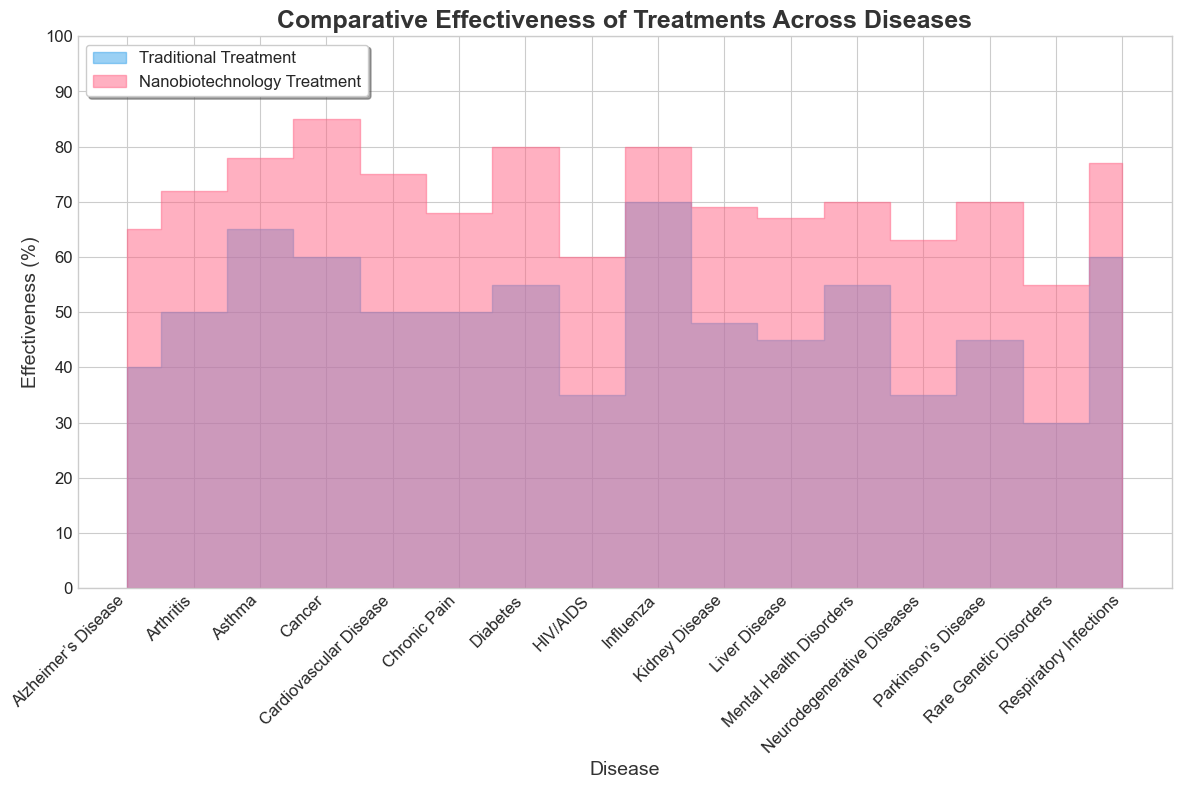Which treatment is overall more effective across most diseases? Nanobiotechnology appears to have higher effectiveness values than traditional treatment across most diseases, as seen by the larger area under the red curve compared to the blue one.
Answer: Nanobiotechnology Which disease shows the smallest difference in effectiveness between the two treatments? For Influenza, the effectiveness values are 70% for traditional treatment and 80% for nanobiotechnology, resulting in a difference of 10%, which is the smallest difference among all the diseases.
Answer: Influenza Which disease has the highest effectiveness for traditional treatments? The tallest point in the blue area, representing traditional treatment effectiveness, is seen for Influenza, at 70%.
Answer: Influenza What is the average effectiveness of nanobiotechnology treatments across all diseases? Summing all the effectiveness values of nanobiotechnology and dividing by the number of diseases: (85+75+80+65+70+80+60+78+72+70+55+68+67+69+77+63) / 16 = 70.
Answer: 70 What is the range of effectiveness for traditional treatments across the diseases? The minimum effectiveness for traditional treatments is 30% (Rare Genetic Disorders) and the maximum is 70% (Influenza). So, the range is 70% - 30% = 40%.
Answer: 40% Does any disease show equal effectiveness for both treatment methods? No. By observing the plot, none of the disease effectiveness values are equal between the traditional and nanobiotechnology treatments.
Answer: No Which disease shows the largest improvement in effectiveness with nanobiotechnology treatment compared to traditional treatment? Cancer shows an improvement from 60% (traditional) to 85% (nano), a difference of 25%.
Answer: Cancer How do the effectiveness levels for nanobiotechnology treatments of Asthma and Arthritis compare? The red area height for Asthma (78%) is slightly higher than that for Arthritis (72%), indicating that nanobiotechnology is more effective for Asthma than for Arthritis.
Answer: Asthma is higher Is there any disease for which traditional treatment is more effective than nanobiotechnology treatment? No. The plot shows that for every disease, the red area (nanobiotechnology) is always above or equal to the blue area (traditional), indicating greater or equal effectiveness.
Answer: No 